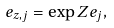Convert formula to latex. <formula><loc_0><loc_0><loc_500><loc_500>e _ { z , j } = \exp Z e _ { j } ,</formula> 